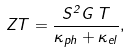Convert formula to latex. <formula><loc_0><loc_0><loc_500><loc_500>Z T = \frac { S ^ { 2 } G \, T } { \kappa _ { p h } + \kappa _ { e l } } , \\</formula> 